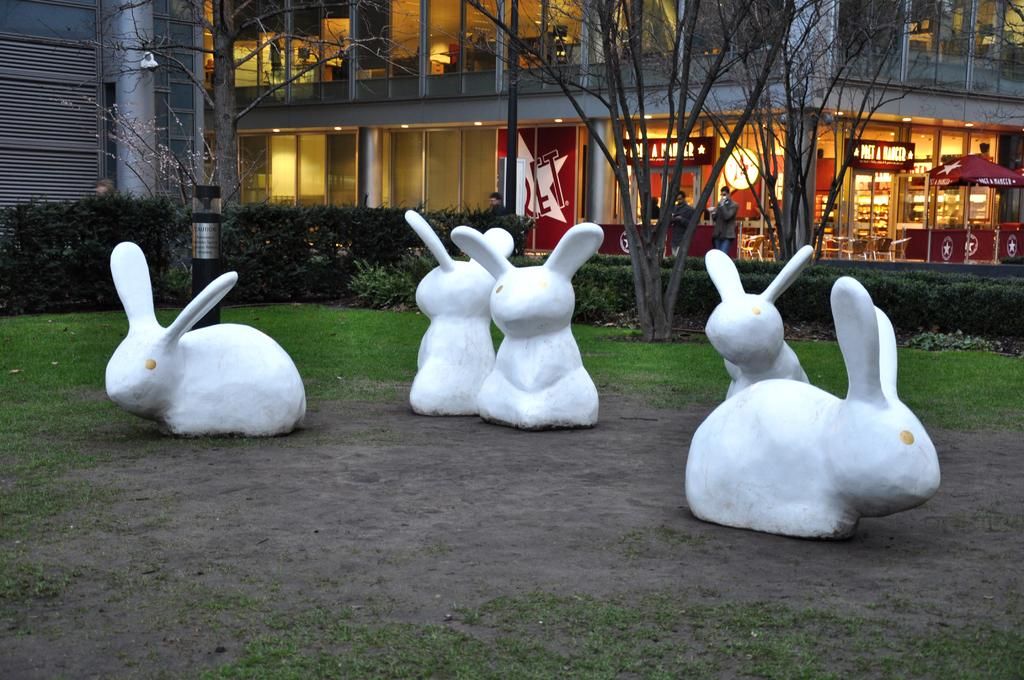What type of animals are depicted as statues in the image? There are statues of rabbits in the image. Where are the rabbit statues located? The statues are kept on the ground. What can be seen in the background of the image? There is a building in the background of the image. Are there any people present in the image? Yes, there are people standing near the building. What type of vegetation is visible in the image? There are trees in the image. What type of fuel is being used by the rabbit statues in the image? There is no fuel being used by the rabbit statues in the image, as they are statues and not living beings. 